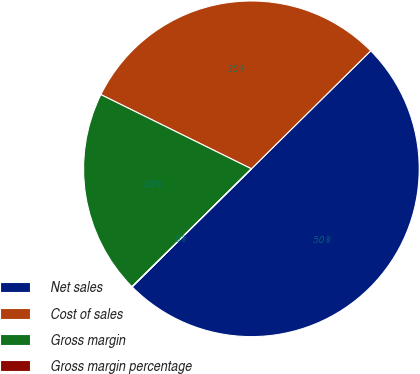<chart> <loc_0><loc_0><loc_500><loc_500><pie_chart><fcel>Net sales<fcel>Cost of sales<fcel>Gross margin<fcel>Gross margin percentage<nl><fcel>49.98%<fcel>30.3%<fcel>19.68%<fcel>0.03%<nl></chart> 